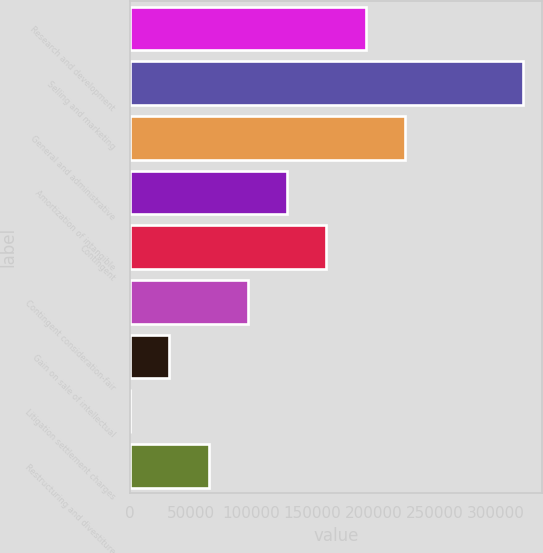Convert chart to OTSL. <chart><loc_0><loc_0><loc_500><loc_500><bar_chart><fcel>Research and development<fcel>Selling and marketing<fcel>General and administrative<fcel>Amortization of intangible<fcel>Contingent<fcel>Contingent consideration-fair<fcel>Gain on sale of intellectual<fcel>Litigation settlement charges<fcel>Restructuring and divestiture<nl><fcel>193569<fcel>322314<fcel>225755<fcel>129197<fcel>161383<fcel>97010.6<fcel>32638.2<fcel>452<fcel>64824.4<nl></chart> 